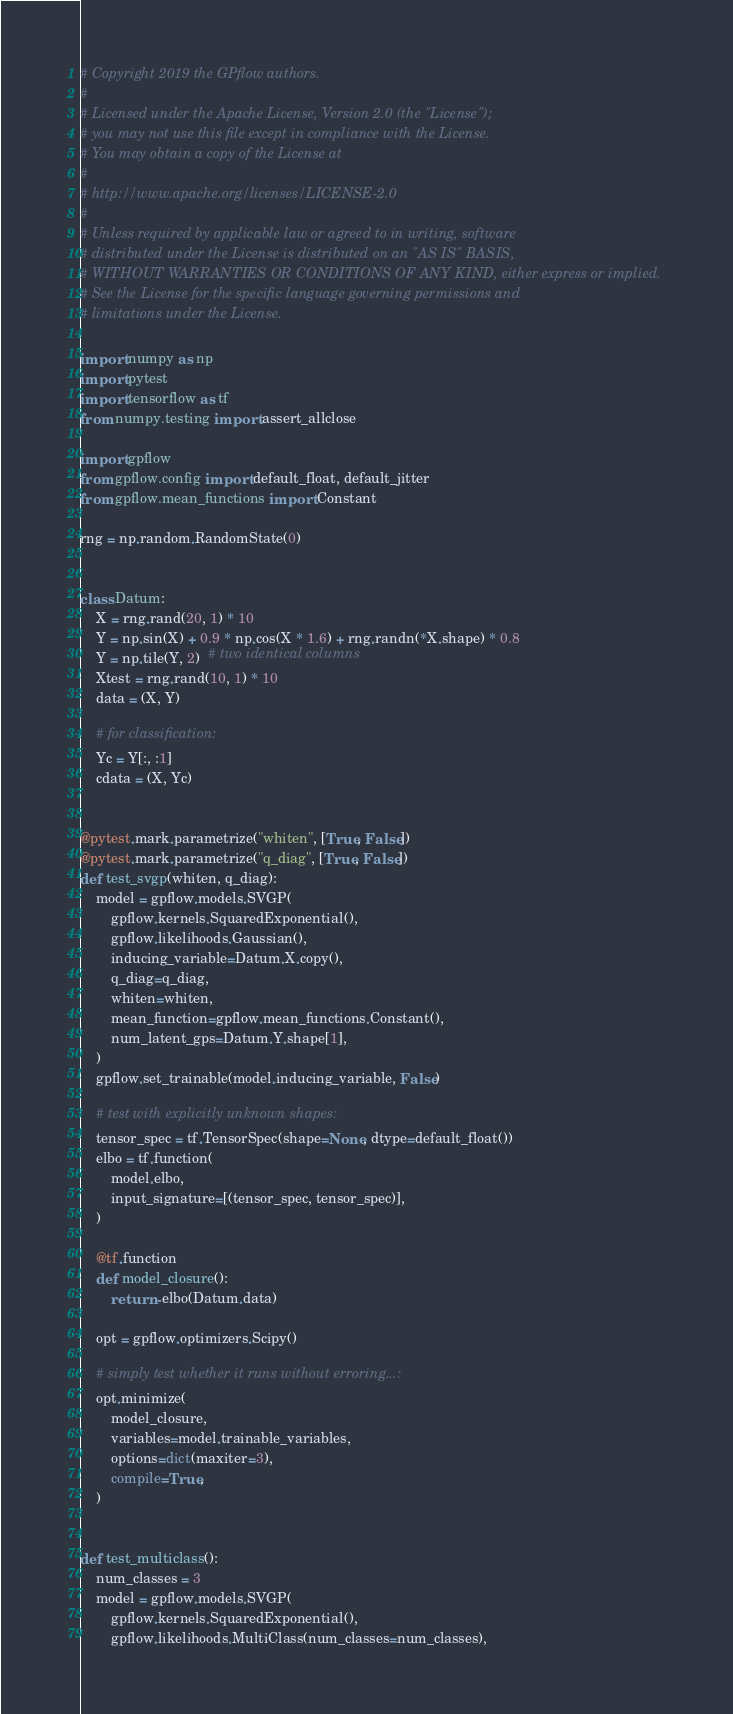Convert code to text. <code><loc_0><loc_0><loc_500><loc_500><_Python_># Copyright 2019 the GPflow authors.
#
# Licensed under the Apache License, Version 2.0 (the "License");
# you may not use this file except in compliance with the License.
# You may obtain a copy of the License at
#
# http://www.apache.org/licenses/LICENSE-2.0
#
# Unless required by applicable law or agreed to in writing, software
# distributed under the License is distributed on an "AS IS" BASIS,
# WITHOUT WARRANTIES OR CONDITIONS OF ANY KIND, either express or implied.
# See the License for the specific language governing permissions and
# limitations under the License.

import numpy as np
import pytest
import tensorflow as tf
from numpy.testing import assert_allclose

import gpflow
from gpflow.config import default_float, default_jitter
from gpflow.mean_functions import Constant

rng = np.random.RandomState(0)


class Datum:
    X = rng.rand(20, 1) * 10
    Y = np.sin(X) + 0.9 * np.cos(X * 1.6) + rng.randn(*X.shape) * 0.8
    Y = np.tile(Y, 2)  # two identical columns
    Xtest = rng.rand(10, 1) * 10
    data = (X, Y)

    # for classification:
    Yc = Y[:, :1]
    cdata = (X, Yc)


@pytest.mark.parametrize("whiten", [True, False])
@pytest.mark.parametrize("q_diag", [True, False])
def test_svgp(whiten, q_diag):
    model = gpflow.models.SVGP(
        gpflow.kernels.SquaredExponential(),
        gpflow.likelihoods.Gaussian(),
        inducing_variable=Datum.X.copy(),
        q_diag=q_diag,
        whiten=whiten,
        mean_function=gpflow.mean_functions.Constant(),
        num_latent_gps=Datum.Y.shape[1],
    )
    gpflow.set_trainable(model.inducing_variable, False)

    # test with explicitly unknown shapes:
    tensor_spec = tf.TensorSpec(shape=None, dtype=default_float())
    elbo = tf.function(
        model.elbo,
        input_signature=[(tensor_spec, tensor_spec)],
    )

    @tf.function
    def model_closure():
        return -elbo(Datum.data)

    opt = gpflow.optimizers.Scipy()

    # simply test whether it runs without erroring...:
    opt.minimize(
        model_closure,
        variables=model.trainable_variables,
        options=dict(maxiter=3),
        compile=True,
    )


def test_multiclass():
    num_classes = 3
    model = gpflow.models.SVGP(
        gpflow.kernels.SquaredExponential(),
        gpflow.likelihoods.MultiClass(num_classes=num_classes),</code> 